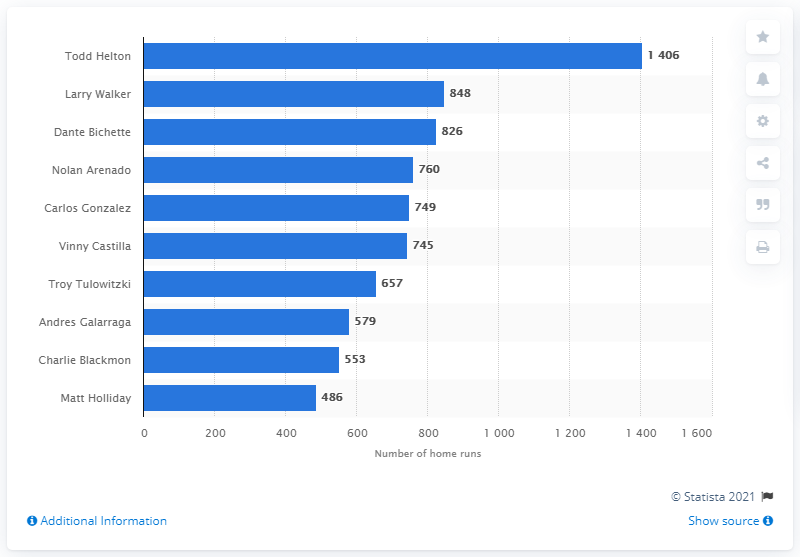Mention a couple of crucial points in this snapshot. The Colorado Rockies franchise has seen many skilled hitters over the years, but none have amassed more RBIs than Todd Helton. 